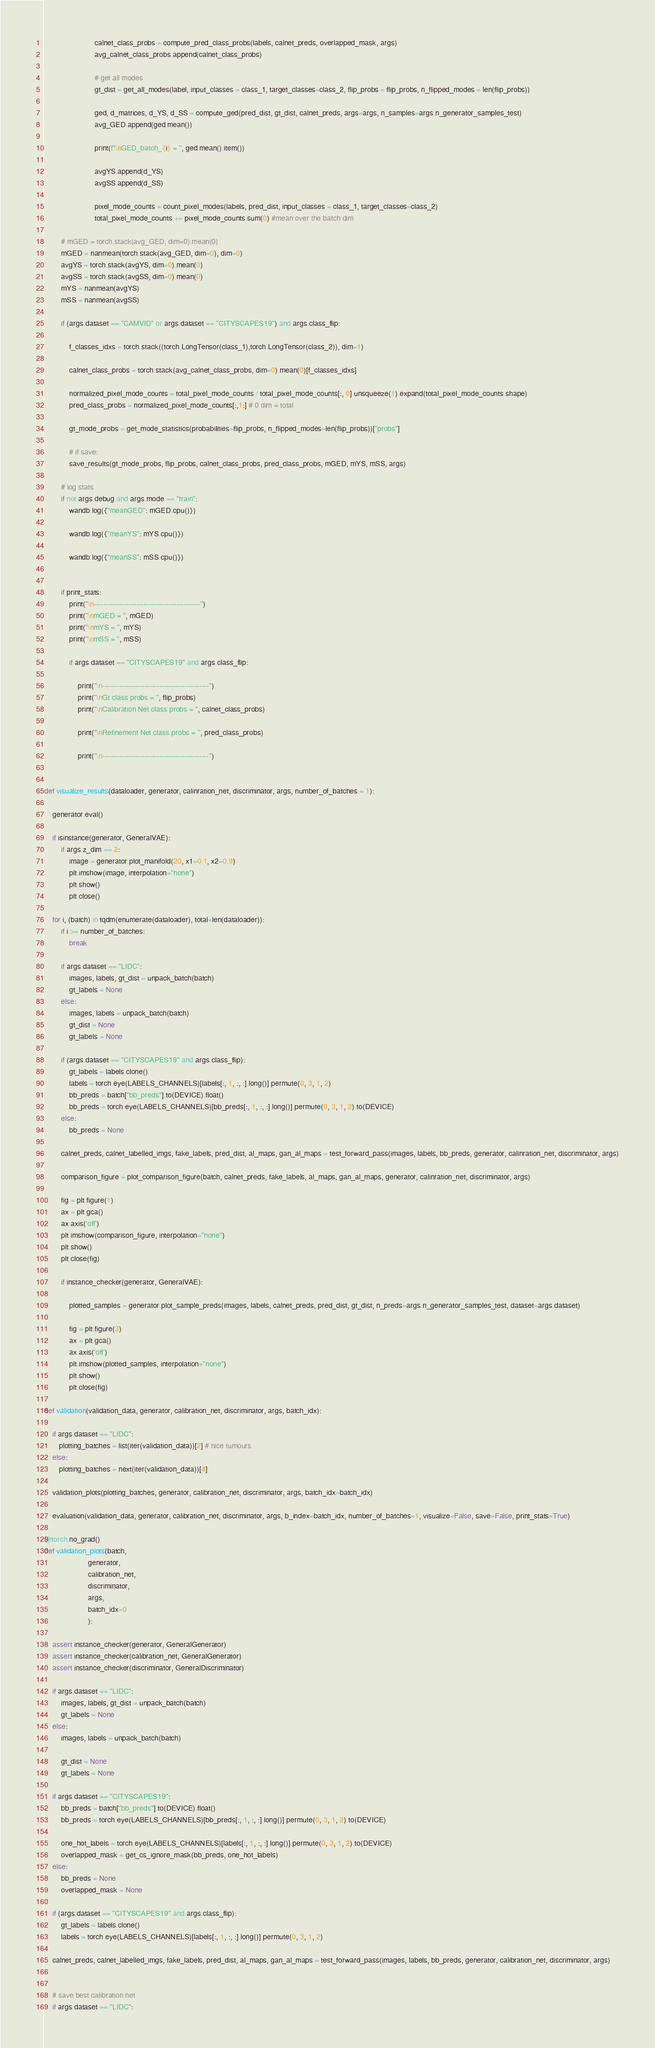<code> <loc_0><loc_0><loc_500><loc_500><_Python_>                        calnet_class_probs = compute_pred_class_probs(labels, calnet_preds, overlapped_mask, args)
                        avg_calnet_class_probs.append(calnet_class_probs)

                        # get all modes
                        gt_dist = get_all_modes(label, input_classes = class_1, target_classes=class_2, flip_probs = flip_probs, n_flipped_modes = len(flip_probs))

                        ged, d_matrices, d_YS, d_SS = compute_ged(pred_dist, gt_dist, calnet_preds, args=args, n_samples=args.n_generator_samples_test)
                        avg_GED.append(ged.mean())

                        print(f"\nGED_batch_{i} = ", ged.mean().item())

                        avgYS.append(d_YS)
                        avgSS.append(d_SS)

                        pixel_mode_counts = count_pixel_modes(labels, pred_dist, input_classes = class_1, target_classes=class_2)
                        total_pixel_mode_counts += pixel_mode_counts.sum(0) #mean over the batch dim

        # mGED = torch.stack(avg_GED, dim=0).mean(0)
        mGED = nanmean(torch.stack(avg_GED, dim=0), dim=0)
        avgYS = torch.stack(avgYS, dim=0).mean(0)
        avgSS = torch.stack(avgSS, dim=0).mean(0)
        mYS = nanmean(avgYS)
        mSS = nanmean(avgSS)

        if (args.dataset == "CAMVID" or args.dataset == "CITYSCAPES19") and args.class_flip:

            f_classes_idxs = torch.stack((torch.LongTensor(class_1),torch.LongTensor(class_2)), dim=1)

            calnet_class_probs = torch.stack(avg_calnet_class_probs, dim=0).mean(0)[f_classes_idxs]

            normalized_pixel_mode_counts = total_pixel_mode_counts / total_pixel_mode_counts[:, 0].unsqueeze(1).expand(total_pixel_mode_counts.shape)
            pred_class_probs = normalized_pixel_mode_counts[:,1:] # 0 dim = total

            gt_mode_probs = get_mode_statistics(probabilities=flip_probs, n_flipped_modes=len(flip_probs))["probs"]

            # if save:
            save_results(gt_mode_probs, flip_probs, calnet_class_probs, pred_class_probs, mGED, mYS, mSS, args)

        # log stats
        if not args.debug and args.mode == "train":
            wandb.log({"meanGED": mGED.cpu()})

            wandb.log({"meanYS": mYS.cpu()})

            wandb.log({"meanSS": mSS.cpu()})


        if print_stats:
            print("\n---------------------------------------------")
            print("\nmGED = ", mGED)
            print("\nmYS = ", mYS)
            print("\nmSS = ", mSS)

            if args.dataset == "CITYSCAPES19" and args.class_flip:

                print("\n---------------------------------------------")
                print("\nGt class probs = ", flip_probs)
                print("\nCalibration Net class probs = ", calnet_class_probs)

                print("\nRefinement Net class probs = ", pred_class_probs)

                print("\n---------------------------------------------")


def visualize_results(dataloader, generator, calinration_net, discriminator, args, number_of_batches = 1):

    generator.eval()

    if isinstance(generator, GeneralVAE):
        if args.z_dim == 2:
            image = generator.plot_manifold(20, x1=0.1, x2=0.9)
            plt.imshow(image, interpolation="none")
            plt.show()
            plt.close()

    for i, (batch) in tqdm(enumerate(dataloader), total=len(dataloader)):
        if i >= number_of_batches:
            break

        if args.dataset == "LIDC":
            images, labels, gt_dist = unpack_batch(batch)
            gt_labels = None
        else:
            images, labels = unpack_batch(batch)
            gt_dist = None
            gt_labels = None

        if (args.dataset == "CITYSCAPES19" and args.class_flip):
            gt_labels = labels.clone()
            labels = torch.eye(LABELS_CHANNELS)[labels[:, 1, :, :].long()].permute(0, 3, 1, 2)
            bb_preds = batch["bb_preds"].to(DEVICE).float()
            bb_preds = torch.eye(LABELS_CHANNELS)[bb_preds[:, 1, :, :].long()].permute(0, 3, 1, 2).to(DEVICE)
        else:
            bb_preds = None

        calnet_preds, calnet_labelled_imgs, fake_labels, pred_dist, al_maps, gan_al_maps = test_forward_pass(images, labels, bb_preds, generator, calinration_net, discriminator, args)

        comparison_figure = plot_comparison_figure(batch, calnet_preds, fake_labels, al_maps, gan_al_maps, generator, calinration_net, discriminator, args)

        fig = plt.figure(1)
        ax = plt.gca()
        ax.axis('off')
        plt.imshow(comparison_figure, interpolation="none")
        plt.show()
        plt.close(fig)

        if instance_checker(generator, GeneralVAE):

            plotted_samples = generator.plot_sample_preds(images, labels, calnet_preds, pred_dist, gt_dist, n_preds=args.n_generator_samples_test, dataset=args.dataset)

            fig = plt.figure(3)
            ax = plt.gca()
            ax.axis('off')
            plt.imshow(plotted_samples, interpolation="none")
            plt.show()
            plt.close(fig)

def validation(validation_data, generator, calibration_net, discriminator, args, batch_idx):

    if args.dataset == "LIDC":
       plotting_batches = list(iter(validation_data))[2] # nice tumours
    else:
       plotting_batches = next(iter(validation_data))[4]

    validation_plots(plotting_batches, generator, calibration_net, discriminator, args, batch_idx=batch_idx)

    evaluation(validation_data, generator, calibration_net, discriminator, args, b_index=batch_idx, number_of_batches=1, visualize=False, save=False, print_stats=True)

@torch.no_grad()
def validation_plots(batch,
                     generator,
                     calibration_net,
                     discriminator,
                     args,
                     batch_idx=0
                     ):

    assert instance_checker(generator, GeneralGenerator)
    assert instance_checker(calibration_net, GeneralGenerator)
    assert instance_checker(discriminator, GeneralDiscriminator)

    if args.dataset == "LIDC":
        images, labels, gt_dist = unpack_batch(batch)
        gt_labels = None
    else:
        images, labels = unpack_batch(batch)

        gt_dist = None
        gt_labels = None

    if args.dataset == "CITYSCAPES19":
        bb_preds = batch["bb_preds"].to(DEVICE).float()
        bb_preds = torch.eye(LABELS_CHANNELS)[bb_preds[:, 1, :, :].long()].permute(0, 3, 1, 2).to(DEVICE)

        one_hot_labels = torch.eye(LABELS_CHANNELS)[labels[:, 1, :, :].long()].permute(0, 3, 1, 2).to(DEVICE)
        overlapped_mask = get_cs_ignore_mask(bb_preds, one_hot_labels)
    else:
        bb_preds = None
        overlapped_mask = None

    if (args.dataset == "CITYSCAPES19" and args.class_flip):
        gt_labels = labels.clone()
        labels = torch.eye(LABELS_CHANNELS)[labels[:, 1, :, :].long()].permute(0, 3, 1, 2)

    calnet_preds, calnet_labelled_imgs, fake_labels, pred_dist, al_maps, gan_al_maps = test_forward_pass(images, labels, bb_preds, generator, calibration_net, discriminator, args)


    # save best calibration net
    if args.dataset == "LIDC":</code> 